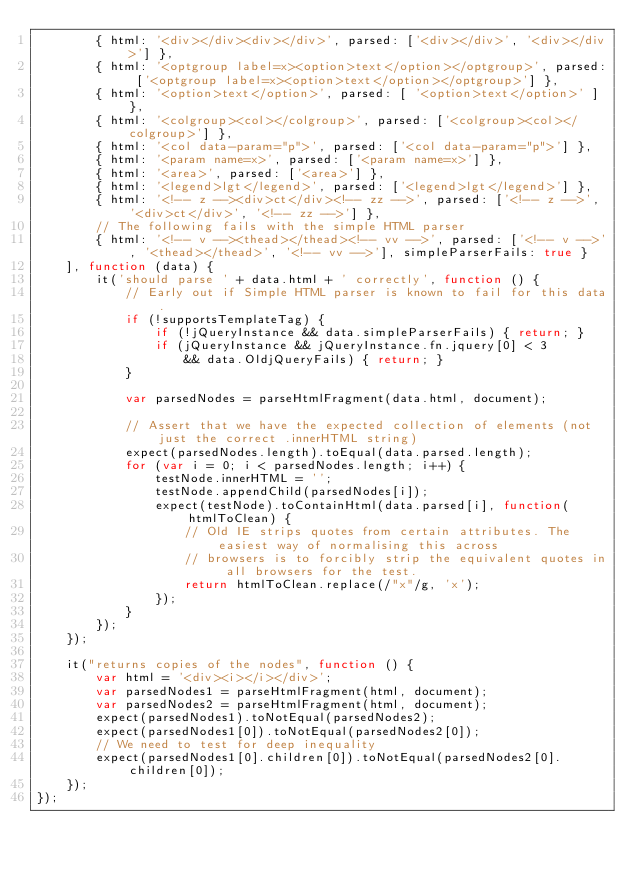<code> <loc_0><loc_0><loc_500><loc_500><_JavaScript_>        { html: '<div></div><div></div>', parsed: ['<div></div>', '<div></div>'] },
        { html: '<optgroup label=x><option>text</option></optgroup>', parsed: ['<optgroup label=x><option>text</option></optgroup>'] },
        { html: '<option>text</option>', parsed: [ '<option>text</option>' ] },
        { html: '<colgroup><col></colgroup>', parsed: ['<colgroup><col></colgroup>'] },
        { html: '<col data-param="p">', parsed: ['<col data-param="p">'] },
        { html: '<param name=x>', parsed: ['<param name=x>'] },
        { html: '<area>', parsed: ['<area>'] },
        { html: '<legend>lgt</legend>', parsed: ['<legend>lgt</legend>'] },
        { html: '<!-- z --><div>ct</div><!-- zz -->', parsed: ['<!-- z -->', '<div>ct</div>', '<!-- zz -->'] },
        // The following fails with the simple HTML parser
        { html: '<!-- v --><thead></thead><!-- vv -->', parsed: ['<!-- v -->', '<thead></thead>', '<!-- vv -->'], simpleParserFails: true }
    ], function (data) {
        it('should parse ' + data.html + ' correctly', function () {
            // Early out if Simple HTML parser is known to fail for this data.
            if (!supportsTemplateTag) {
                if (!jQueryInstance && data.simpleParserFails) { return; }
                if (jQueryInstance && jQueryInstance.fn.jquery[0] < 3
                    && data.OldjQueryFails) { return; }
            }

            var parsedNodes = parseHtmlFragment(data.html, document);

            // Assert that we have the expected collection of elements (not just the correct .innerHTML string)
            expect(parsedNodes.length).toEqual(data.parsed.length);
            for (var i = 0; i < parsedNodes.length; i++) {
                testNode.innerHTML = '';
                testNode.appendChild(parsedNodes[i]);
                expect(testNode).toContainHtml(data.parsed[i], function(htmlToClean) {
                    // Old IE strips quotes from certain attributes. The easiest way of normalising this across
                    // browsers is to forcibly strip the equivalent quotes in all browsers for the test.
                    return htmlToClean.replace(/"x"/g, 'x');
                });
            }
        });
    });

    it("returns copies of the nodes", function () {
        var html = '<div><i></i></div>';
        var parsedNodes1 = parseHtmlFragment(html, document);
        var parsedNodes2 = parseHtmlFragment(html, document);
        expect(parsedNodes1).toNotEqual(parsedNodes2);
        expect(parsedNodes1[0]).toNotEqual(parsedNodes2[0]);
        // We need to test for deep inequality
        expect(parsedNodes1[0].children[0]).toNotEqual(parsedNodes2[0].children[0]);
    });
});
</code> 